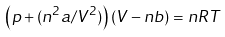Convert formula to latex. <formula><loc_0><loc_0><loc_500><loc_500>\left ( p + ( { n ^ { 2 } a } / { V ^ { 2 } } ) \right ) \left ( V - n b \right ) = n R T</formula> 